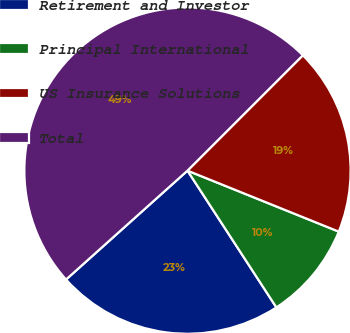Convert chart. <chart><loc_0><loc_0><loc_500><loc_500><pie_chart><fcel>Retirement and Investor<fcel>Principal International<fcel>US Insurance Solutions<fcel>Total<nl><fcel>22.54%<fcel>9.73%<fcel>18.6%<fcel>49.14%<nl></chart> 